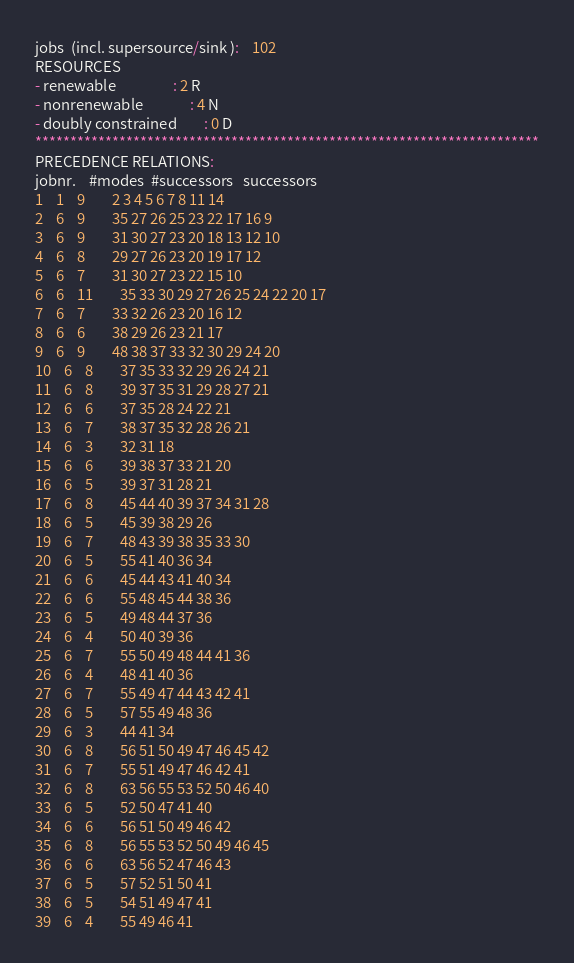Convert code to text. <code><loc_0><loc_0><loc_500><loc_500><_ObjectiveC_>jobs  (incl. supersource/sink ):	102
RESOURCES
- renewable                 : 2 R
- nonrenewable              : 4 N
- doubly constrained        : 0 D
************************************************************************
PRECEDENCE RELATIONS:
jobnr.    #modes  #successors   successors
1	1	9		2 3 4 5 6 7 8 11 14 
2	6	9		35 27 26 25 23 22 17 16 9 
3	6	9		31 30 27 23 20 18 13 12 10 
4	6	8		29 27 26 23 20 19 17 12 
5	6	7		31 30 27 23 22 15 10 
6	6	11		35 33 30 29 27 26 25 24 22 20 17 
7	6	7		33 32 26 23 20 16 12 
8	6	6		38 29 26 23 21 17 
9	6	9		48 38 37 33 32 30 29 24 20 
10	6	8		37 35 33 32 29 26 24 21 
11	6	8		39 37 35 31 29 28 27 21 
12	6	6		37 35 28 24 22 21 
13	6	7		38 37 35 32 28 26 21 
14	6	3		32 31 18 
15	6	6		39 38 37 33 21 20 
16	6	5		39 37 31 28 21 
17	6	8		45 44 40 39 37 34 31 28 
18	6	5		45 39 38 29 26 
19	6	7		48 43 39 38 35 33 30 
20	6	5		55 41 40 36 34 
21	6	6		45 44 43 41 40 34 
22	6	6		55 48 45 44 38 36 
23	6	5		49 48 44 37 36 
24	6	4		50 40 39 36 
25	6	7		55 50 49 48 44 41 36 
26	6	4		48 41 40 36 
27	6	7		55 49 47 44 43 42 41 
28	6	5		57 55 49 48 36 
29	6	3		44 41 34 
30	6	8		56 51 50 49 47 46 45 42 
31	6	7		55 51 49 47 46 42 41 
32	6	8		63 56 55 53 52 50 46 40 
33	6	5		52 50 47 41 40 
34	6	6		56 51 50 49 46 42 
35	6	8		56 55 53 52 50 49 46 45 
36	6	6		63 56 52 47 46 43 
37	6	5		57 52 51 50 41 
38	6	5		54 51 49 47 41 
39	6	4		55 49 46 41 </code> 